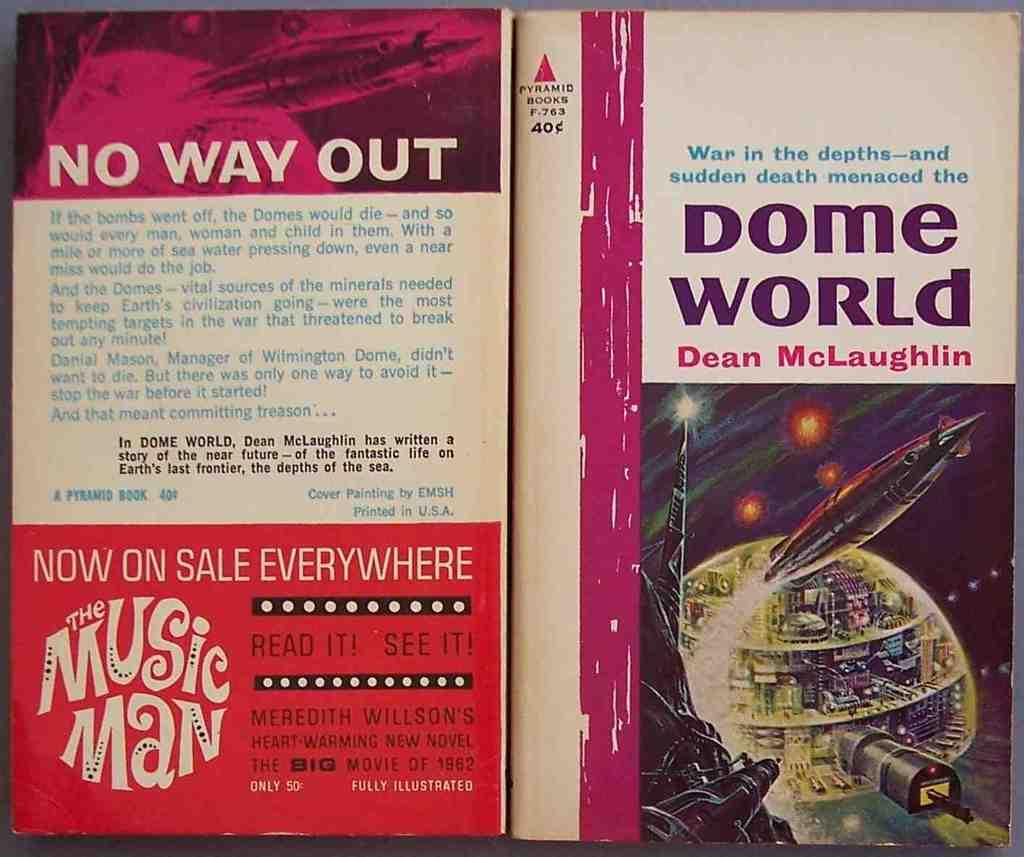How many books are visible in the image? There are two books in the image. Where are the books located? The books are placed on a surface. What can be found on the books? The books have pictures and text on them. Are there any ants crawling on the books in the image? There is no mention of ants in the image, so we cannot determine if they are present or not. 